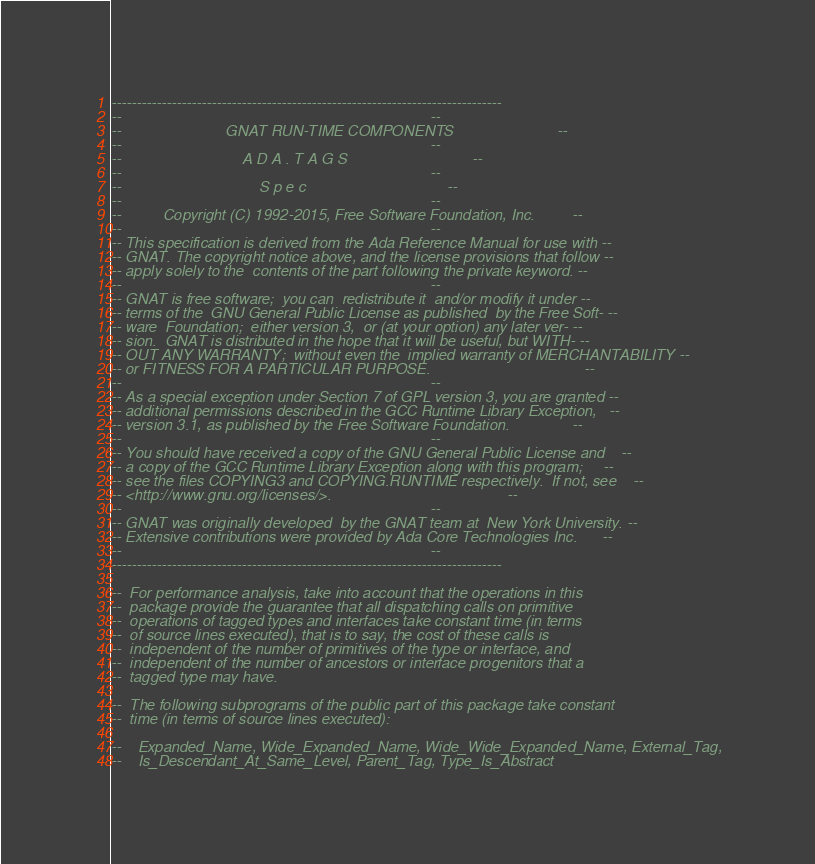Convert code to text. <code><loc_0><loc_0><loc_500><loc_500><_Ada_>------------------------------------------------------------------------------
--                                                                          --
--                         GNAT RUN-TIME COMPONENTS                         --
--                                                                          --
--                             A D A . T A G S                              --
--                                                                          --
--                                 S p e c                                  --
--                                                                          --
--          Copyright (C) 1992-2015, Free Software Foundation, Inc.         --
--                                                                          --
-- This specification is derived from the Ada Reference Manual for use with --
-- GNAT. The copyright notice above, and the license provisions that follow --
-- apply solely to the  contents of the part following the private keyword. --
--                                                                          --
-- GNAT is free software;  you can  redistribute it  and/or modify it under --
-- terms of the  GNU General Public License as published  by the Free Soft- --
-- ware  Foundation;  either version 3,  or (at your option) any later ver- --
-- sion.  GNAT is distributed in the hope that it will be useful, but WITH- --
-- OUT ANY WARRANTY;  without even the  implied warranty of MERCHANTABILITY --
-- or FITNESS FOR A PARTICULAR PURPOSE.                                     --
--                                                                          --
-- As a special exception under Section 7 of GPL version 3, you are granted --
-- additional permissions described in the GCC Runtime Library Exception,   --
-- version 3.1, as published by the Free Software Foundation.               --
--                                                                          --
-- You should have received a copy of the GNU General Public License and    --
-- a copy of the GCC Runtime Library Exception along with this program;     --
-- see the files COPYING3 and COPYING.RUNTIME respectively.  If not, see    --
-- <http://www.gnu.org/licenses/>.                                          --
--                                                                          --
-- GNAT was originally developed  by the GNAT team at  New York University. --
-- Extensive contributions were provided by Ada Core Technologies Inc.      --
--                                                                          --
------------------------------------------------------------------------------

--  For performance analysis, take into account that the operations in this
--  package provide the guarantee that all dispatching calls on primitive
--  operations of tagged types and interfaces take constant time (in terms
--  of source lines executed), that is to say, the cost of these calls is
--  independent of the number of primitives of the type or interface, and
--  independent of the number of ancestors or interface progenitors that a
--  tagged type may have.

--  The following subprograms of the public part of this package take constant
--  time (in terms of source lines executed):

--    Expanded_Name, Wide_Expanded_Name, Wide_Wide_Expanded_Name, External_Tag,
--    Is_Descendant_At_Same_Level, Parent_Tag, Type_Is_Abstract</code> 